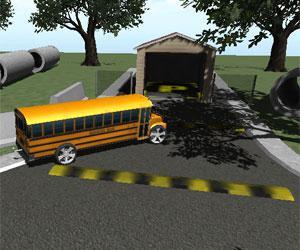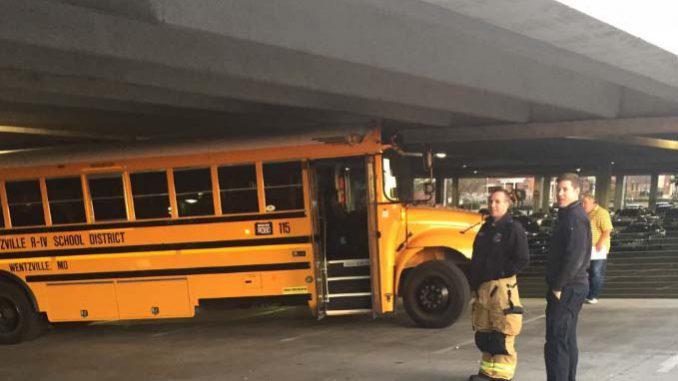The first image is the image on the left, the second image is the image on the right. Assess this claim about the two images: "All the buses are stopped or parked within close proximity to trees.". Correct or not? Answer yes or no. No. 